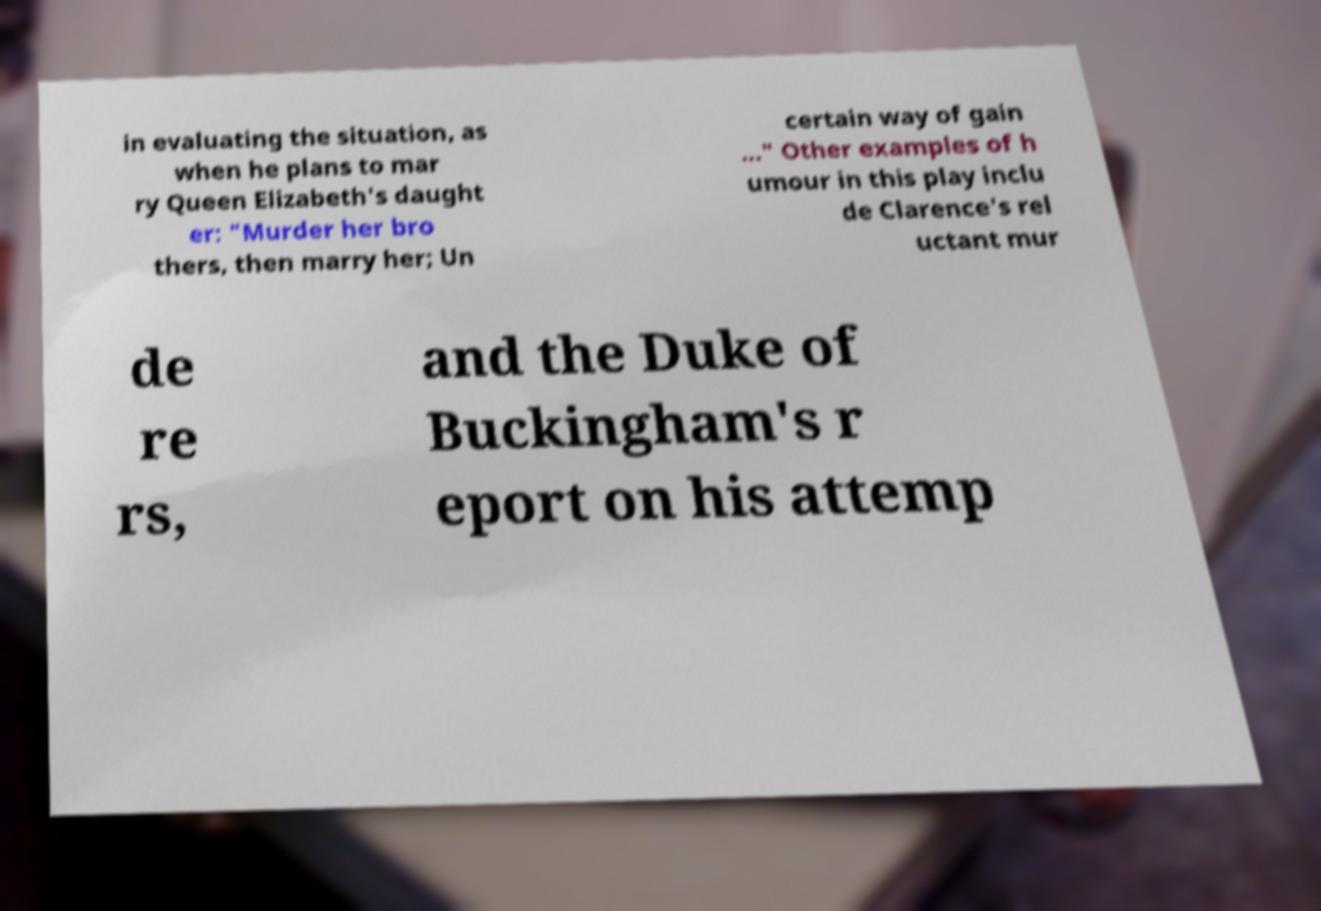Could you assist in decoding the text presented in this image and type it out clearly? in evaluating the situation, as when he plans to mar ry Queen Elizabeth's daught er: "Murder her bro thers, then marry her; Un certain way of gain ..." Other examples of h umour in this play inclu de Clarence's rel uctant mur de re rs, and the Duke of Buckingham's r eport on his attemp 